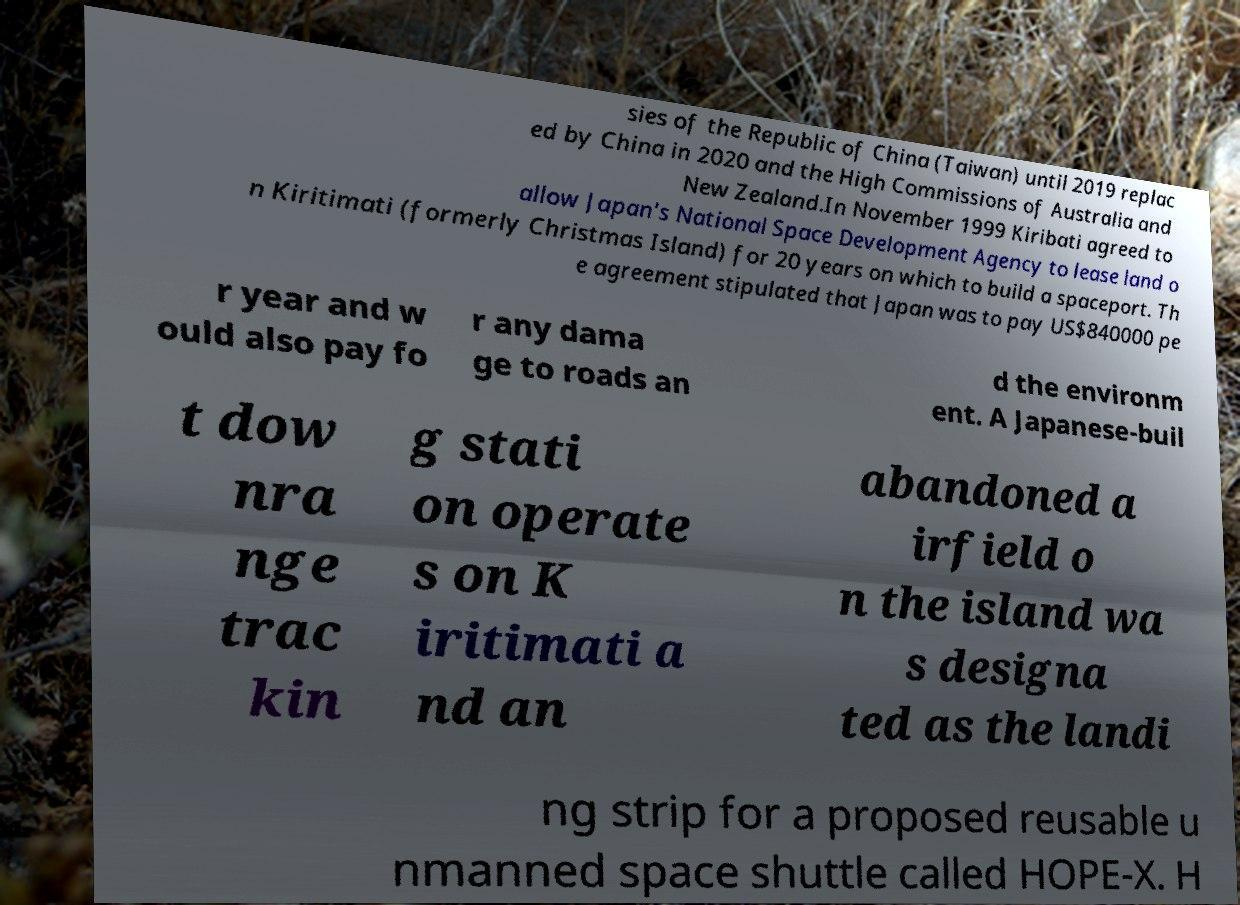I need the written content from this picture converted into text. Can you do that? sies of the Republic of China (Taiwan) until 2019 replac ed by China in 2020 and the High Commissions of Australia and New Zealand.In November 1999 Kiribati agreed to allow Japan's National Space Development Agency to lease land o n Kiritimati (formerly Christmas Island) for 20 years on which to build a spaceport. Th e agreement stipulated that Japan was to pay US$840000 pe r year and w ould also pay fo r any dama ge to roads an d the environm ent. A Japanese-buil t dow nra nge trac kin g stati on operate s on K iritimati a nd an abandoned a irfield o n the island wa s designa ted as the landi ng strip for a proposed reusable u nmanned space shuttle called HOPE-X. H 